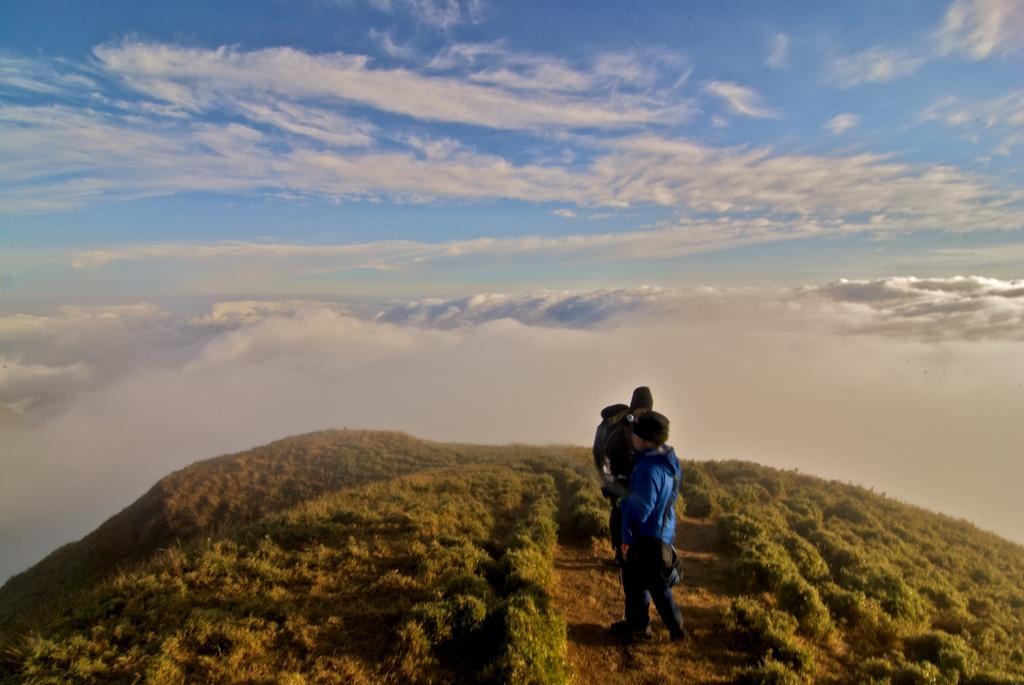How would you summarize this image in a sentence or two? In the picture we can see from a hill and on it we can see plants and some path and on it we can see two people are standing with hoodies and caps and in the background, we can see some hills with snow and some, and behind it we can see a sky with clouds. 